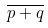Convert formula to latex. <formula><loc_0><loc_0><loc_500><loc_500>\overline { p + q }</formula> 